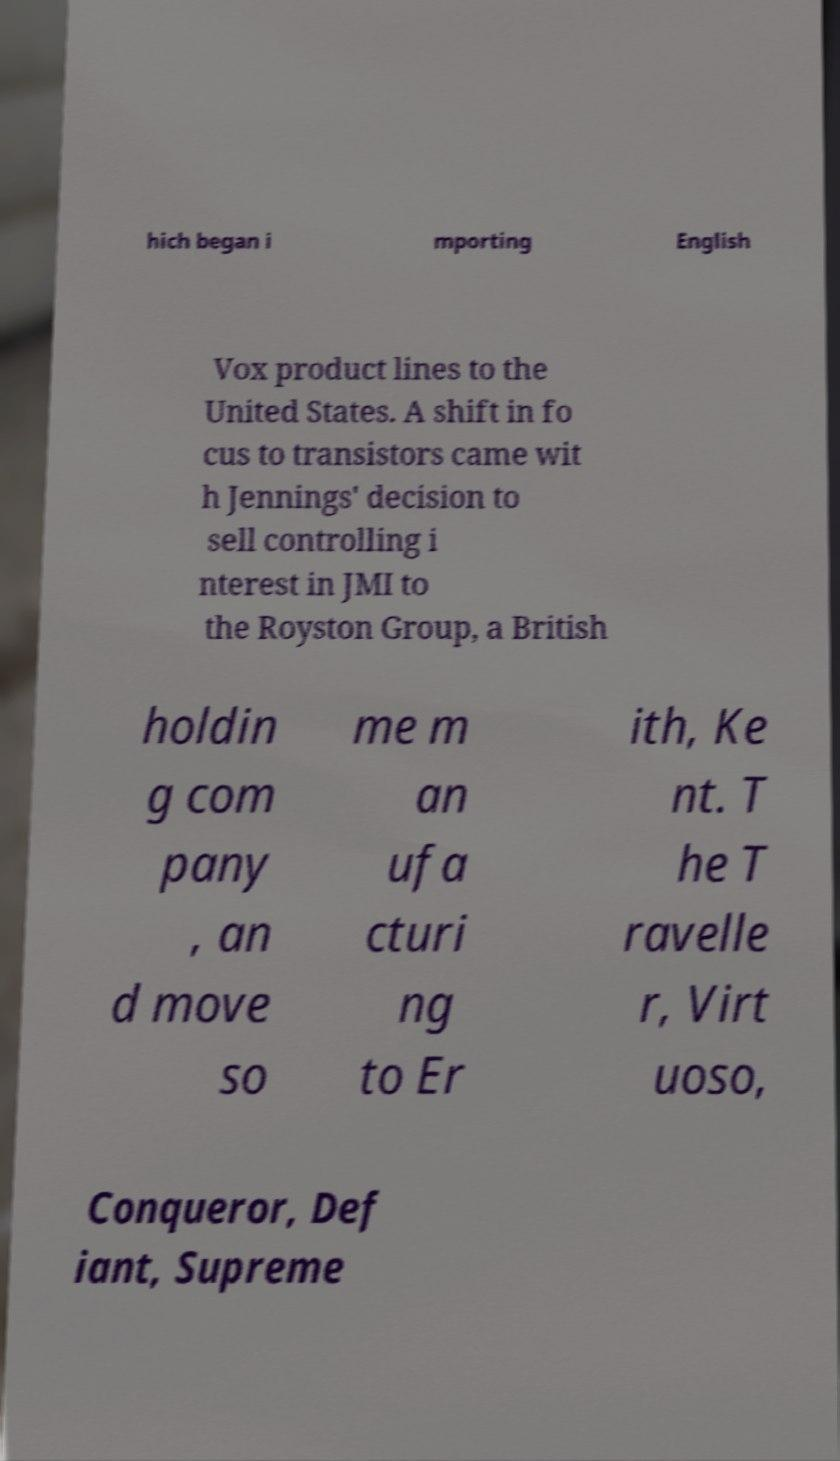What messages or text are displayed in this image? I need them in a readable, typed format. hich began i mporting English Vox product lines to the United States. A shift in fo cus to transistors came wit h Jennings' decision to sell controlling i nterest in JMI to the Royston Group, a British holdin g com pany , an d move so me m an ufa cturi ng to Er ith, Ke nt. T he T ravelle r, Virt uoso, Conqueror, Def iant, Supreme 